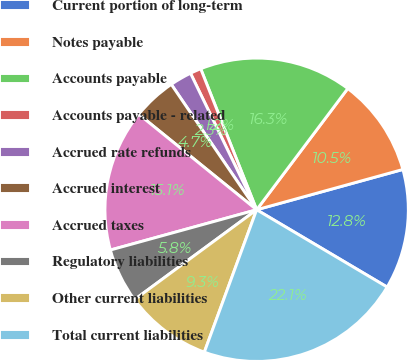Convert chart to OTSL. <chart><loc_0><loc_0><loc_500><loc_500><pie_chart><fcel>Current portion of long-term<fcel>Notes payable<fcel>Accounts payable<fcel>Accounts payable - related<fcel>Accrued rate refunds<fcel>Accrued interest<fcel>Accrued taxes<fcel>Regulatory liabilities<fcel>Other current liabilities<fcel>Total current liabilities<nl><fcel>12.79%<fcel>10.46%<fcel>16.27%<fcel>1.17%<fcel>2.33%<fcel>4.65%<fcel>15.11%<fcel>5.82%<fcel>9.3%<fcel>22.09%<nl></chart> 